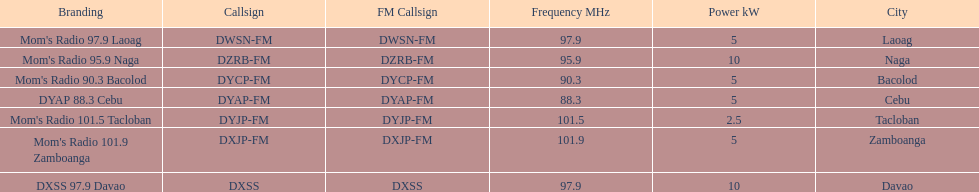How many stations broadcast with a power of 5kw? 4. 